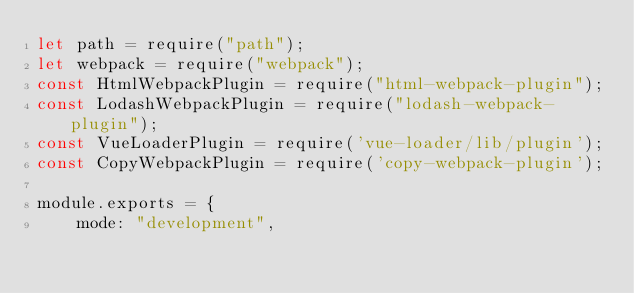<code> <loc_0><loc_0><loc_500><loc_500><_JavaScript_>let path = require("path");
let webpack = require("webpack");
const HtmlWebpackPlugin = require("html-webpack-plugin");
const LodashWebpackPlugin = require("lodash-webpack-plugin");
const VueLoaderPlugin = require('vue-loader/lib/plugin');
const CopyWebpackPlugin = require('copy-webpack-plugin');

module.exports = {
    mode: "development",</code> 